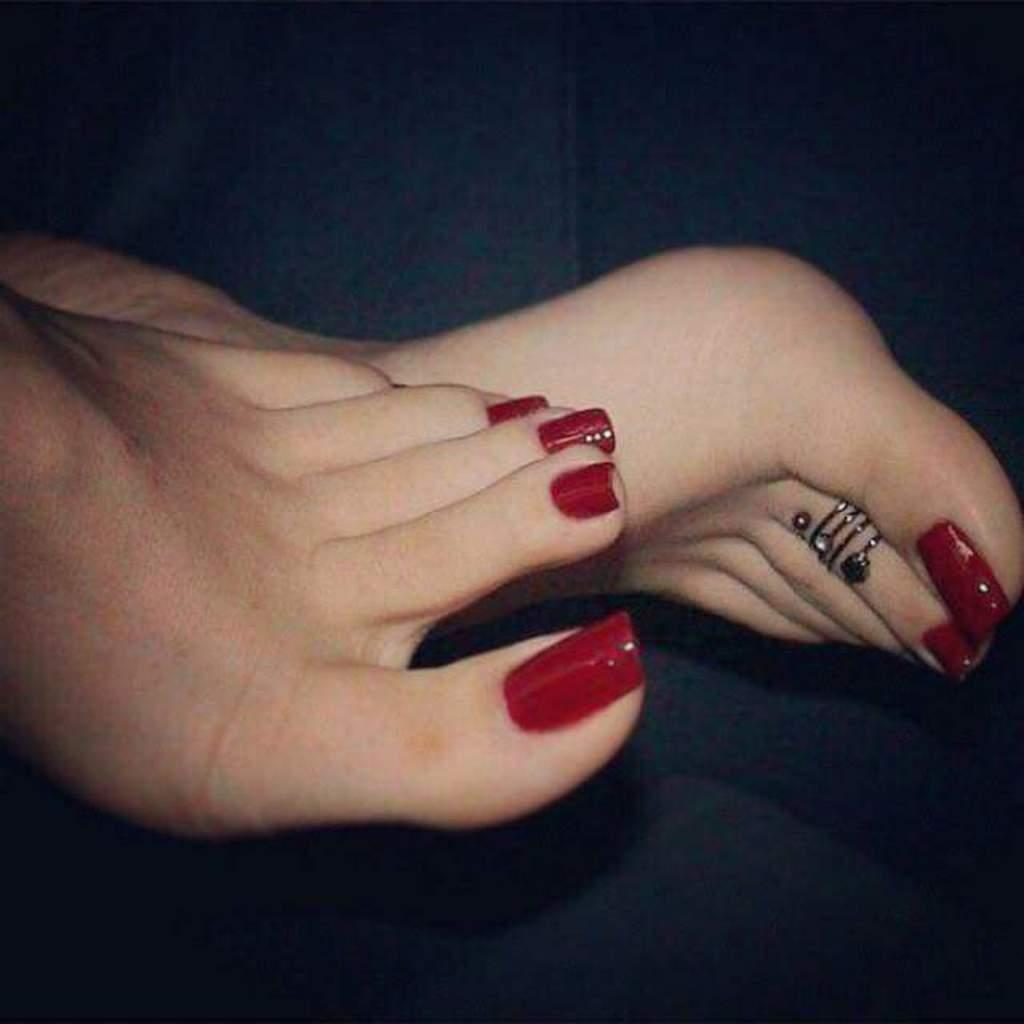What body part is visible in the image? There are legs visible in the image. Can you describe any accessories or adornments on the person's body? There is a toe ring on one of the person's fingers. What type of can is being used to hold the wire in the image? There is no can or wire present in the image. How many cups can be seen in the image? There are no cups visible in the image. 